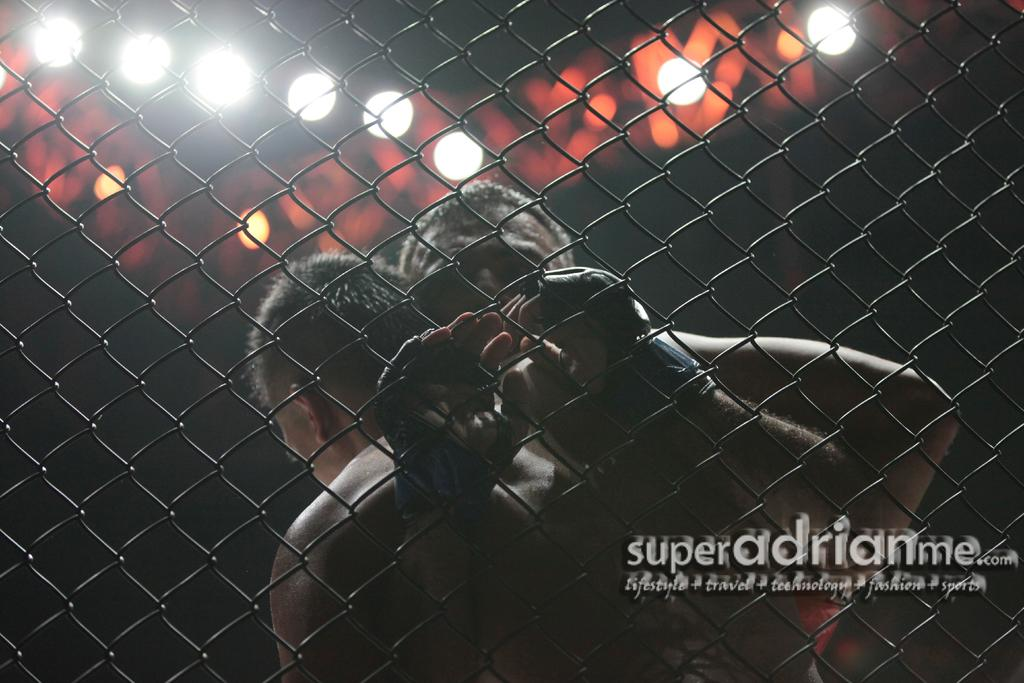What can be observed about the background of the image? The background of the image is blurry. What can be seen in the image besides the background? There are lights visible in the image. Who is present in the image? A: There are men in the image. What might the men be doing in the image? It appears that the men are fighting. What type of material is present in the image? There is a mesh in the image. Is there any text or logo visible in the image? Yes, there is a watermark in the image. What type of reward can be seen in the image? There is no reward present in the image. What belief system do the men in the image follow? There is no information about the men's beliefs in the image. 